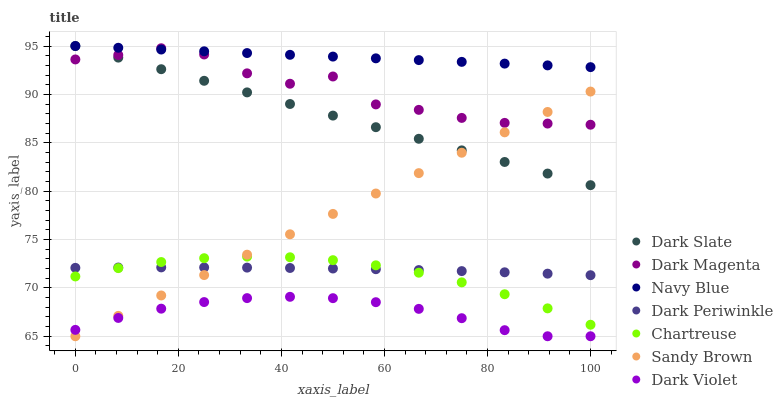Does Dark Violet have the minimum area under the curve?
Answer yes or no. Yes. Does Navy Blue have the maximum area under the curve?
Answer yes or no. Yes. Does Navy Blue have the minimum area under the curve?
Answer yes or no. No. Does Dark Violet have the maximum area under the curve?
Answer yes or no. No. Is Dark Slate the smoothest?
Answer yes or no. Yes. Is Dark Magenta the roughest?
Answer yes or no. Yes. Is Navy Blue the smoothest?
Answer yes or no. No. Is Navy Blue the roughest?
Answer yes or no. No. Does Dark Violet have the lowest value?
Answer yes or no. Yes. Does Navy Blue have the lowest value?
Answer yes or no. No. Does Dark Slate have the highest value?
Answer yes or no. Yes. Does Dark Violet have the highest value?
Answer yes or no. No. Is Dark Violet less than Dark Slate?
Answer yes or no. Yes. Is Dark Magenta greater than Dark Violet?
Answer yes or no. Yes. Does Dark Slate intersect Navy Blue?
Answer yes or no. Yes. Is Dark Slate less than Navy Blue?
Answer yes or no. No. Is Dark Slate greater than Navy Blue?
Answer yes or no. No. Does Dark Violet intersect Dark Slate?
Answer yes or no. No. 